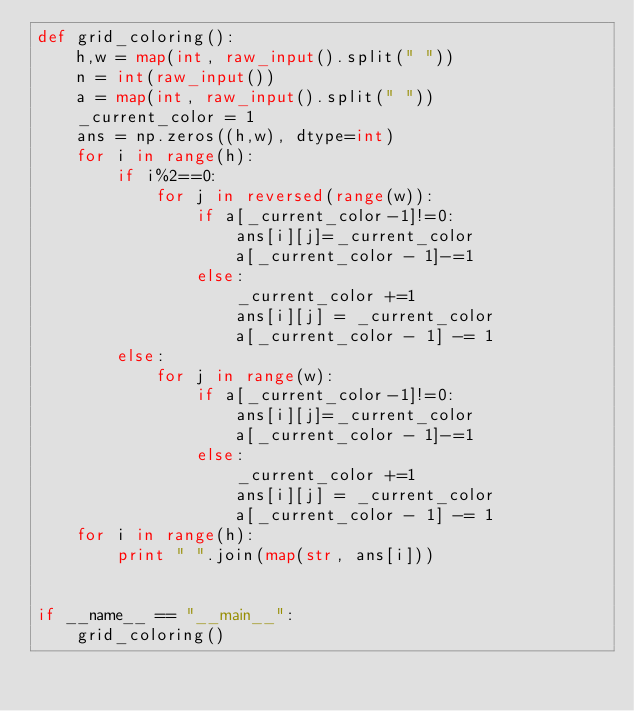<code> <loc_0><loc_0><loc_500><loc_500><_Python_>def grid_coloring():
	h,w = map(int, raw_input().split(" "))
	n = int(raw_input())
	a = map(int, raw_input().split(" "))
	_current_color = 1
	ans = np.zeros((h,w), dtype=int)
	for i in range(h):
		if i%2==0:
			for j in reversed(range(w)):
				if a[_current_color-1]!=0:
					ans[i][j]=_current_color
					a[_current_color - 1]-=1
				else:
					_current_color +=1
					ans[i][j] = _current_color
					a[_current_color - 1] -= 1
		else:
			for j in range(w):
				if a[_current_color-1]!=0:
					ans[i][j]=_current_color
					a[_current_color - 1]-=1
				else:
					_current_color +=1
					ans[i][j] = _current_color
					a[_current_color - 1] -= 1
	for i in range(h):
		print " ".join(map(str, ans[i]))


if __name__ == "__main__":
	grid_coloring()</code> 